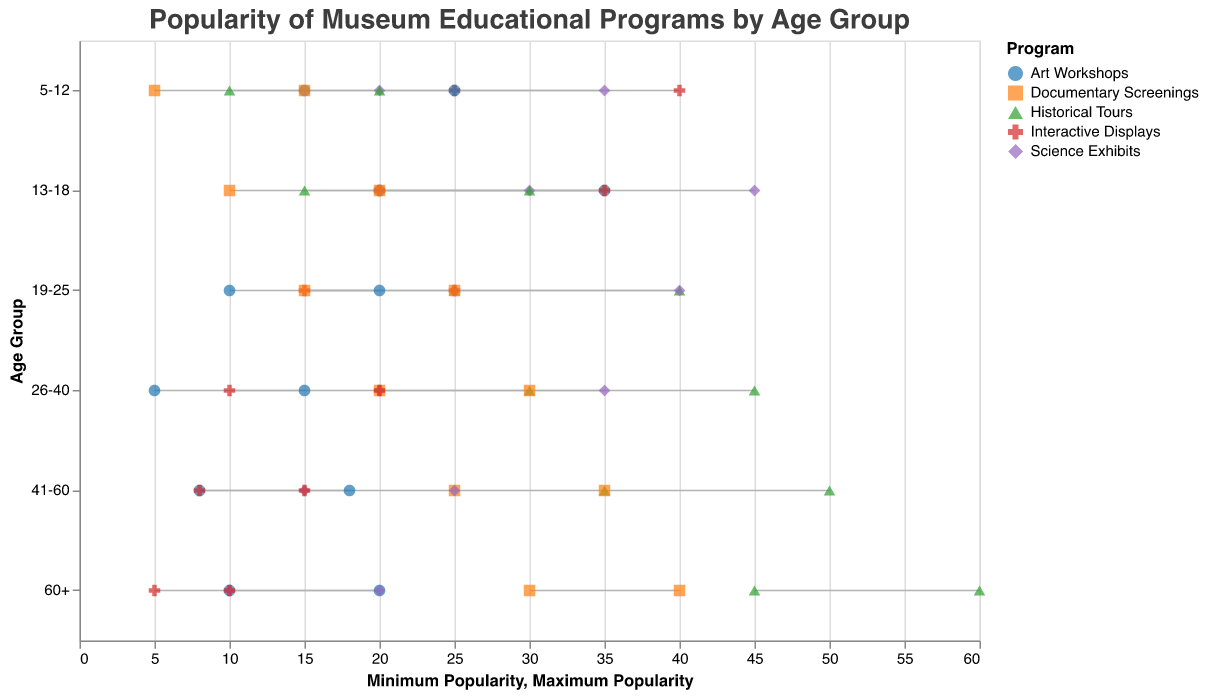What is the minimum popularity range for Art Workshops for the age group 5-12? The figure shows the minimum and maximum popularity for each program across different age groups. For Art Workshops targeting 5-12 years old, the range starts at a minimum of 15 and extends to a maximum of 25.
Answer: 15 Which educational program has the highest maximum popularity for the age group 60+? By referring to the maximum popularity for the age group 60+, we can see that Historical Tours have the highest maximum popularity, which is 60.
Answer: Historical Tours What is the range of popularity for Science Exhibits for the age group 13-18? The figure shows that the minimum popularity for Science Exhibits for the 13-18 age group is 30, and the maximum is 45, making the range 15 (45 - 30).
Answer: 15 Comparing the age group 5-12, which program shows the highest minimum popularity? By looking at the minimum popularity values for the age group 5-12 across all programs, Interactive Displays have the highest minimum popularity of 25.
Answer: Interactive Displays How does the maximum popularity of Documentary Screenings change across the age groups? Referring to the maximum popularity values for Documentary Screenings, they are as follows: 15 (5-12), 20 (13-18), 25 (19-25), 30 (26-40), 35 (41-60), and 40 (60+). There's an increasing trend as the age group progresses.
Answer: Increases with age What is the average of the maximum popularity values for Art Workshops across all age groups? The maximum popularity values for Art Workshops across all age groups are 25, 35, 20, 15, 18, and 20. Adding these values: (25 + 35 + 20 + 15 + 18 + 20) = 133. Dividing by 6 (number of age groups) gives us 133/6 = 22.167.
Answer: 22.167 For the age group 26-40, which program has the widest popularity range? By comparing the popularity ranges for age group 26-40: Art Workshops (5-15), Historical Tours (30-45), Science Exhibits (20-35), Interactive Displays (10-20), and Documentary Screenings (20-30), Historical Tours have the widest range of 15 (45 - 30).
Answer: Historical Tours Is the maximum popularity for Science Exhibits higher than the minimum popularity for Interactive Displays in the age group 19-25? According to the figure, the maximum popularity for Science Exhibits in the 19-25 age group is 40, and the minimum for Interactive Displays is 15. Since 40 > 15, the answer is yes.
Answer: Yes Which program shows the narrowest popularity range across all age groups? To find the program with the narrowest range, we need to inspect the ranges: Art Workshops (ranging from 10-20), Historical Tours (ranging from 10-20), Science Exhibits (ranging from 10-20), Interactive Displays (ranging from 5-10), and Documentary Screenings (ranging from 5-15). The narrowest range is for Interactive Displays 60+ (5-10), which is a range of 5.
Answer: Interactive Displays (60+) For the age group 41-60, which two programs have the closest popularity ranges? The ranges for the 41-60 age group are: Art Workshops (8-18), Historical Tours (35-50), Science Exhibits (15-25), Interactive Displays (8-15), and Documentary Screenings (25-35). The closest ranges are Art Workshops (10) and Interactive Displays (7). So, Interactive Displays and Art Workshops have closest ranges, 7 and 10 respectively.
Answer: Art Workshops and Interactive Displays 